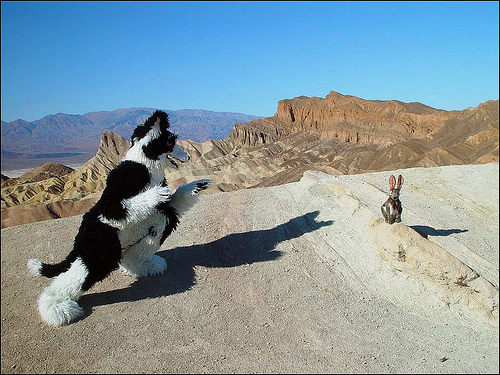<image>
Is there a mountain behind the shadow? Yes. From this viewpoint, the mountain is positioned behind the shadow, with the shadow partially or fully occluding the mountain. 